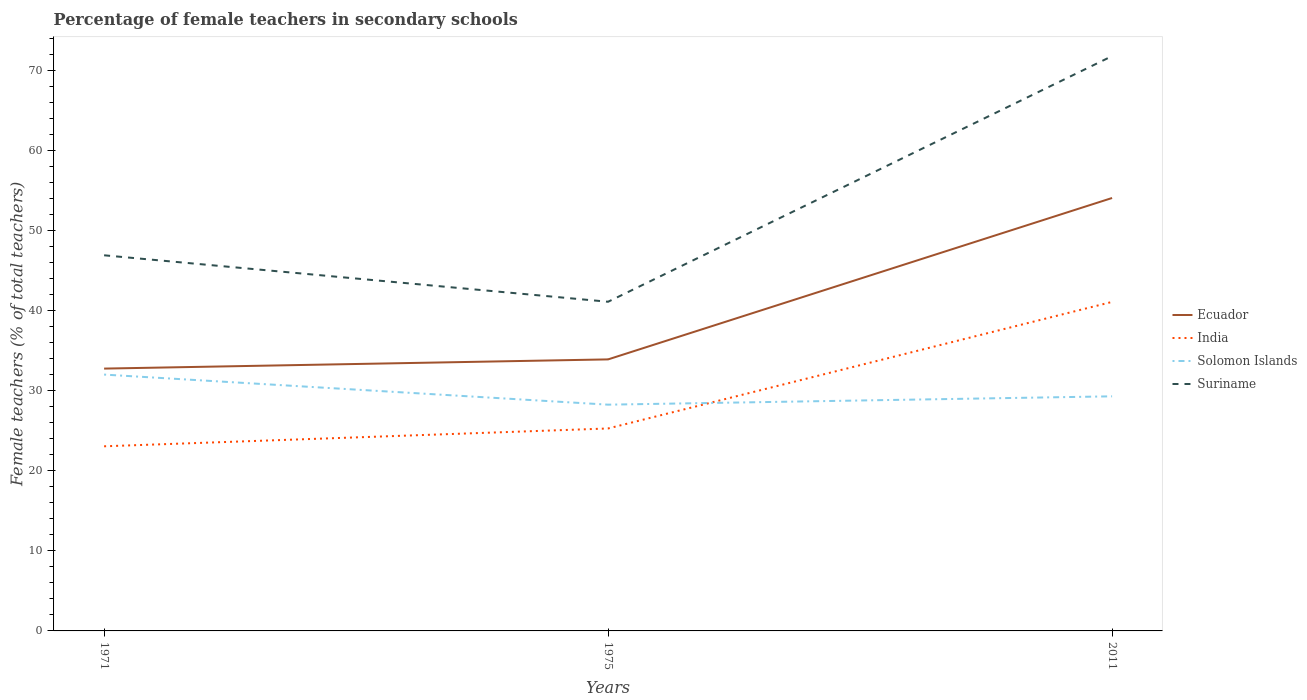Across all years, what is the maximum percentage of female teachers in Solomon Islands?
Keep it short and to the point. 28.24. In which year was the percentage of female teachers in Suriname maximum?
Your response must be concise. 1975. What is the total percentage of female teachers in India in the graph?
Your answer should be compact. -18.03. What is the difference between the highest and the second highest percentage of female teachers in India?
Give a very brief answer. 18.03. How many years are there in the graph?
Your answer should be very brief. 3. What is the difference between two consecutive major ticks on the Y-axis?
Give a very brief answer. 10. Where does the legend appear in the graph?
Give a very brief answer. Center right. How many legend labels are there?
Offer a terse response. 4. What is the title of the graph?
Offer a very short reply. Percentage of female teachers in secondary schools. What is the label or title of the X-axis?
Your answer should be compact. Years. What is the label or title of the Y-axis?
Your response must be concise. Female teachers (% of total teachers). What is the Female teachers (% of total teachers) in Ecuador in 1971?
Your answer should be compact. 32.75. What is the Female teachers (% of total teachers) in India in 1971?
Offer a very short reply. 23.05. What is the Female teachers (% of total teachers) of Solomon Islands in 1971?
Your response must be concise. 32. What is the Female teachers (% of total teachers) of Suriname in 1971?
Make the answer very short. 46.89. What is the Female teachers (% of total teachers) of Ecuador in 1975?
Ensure brevity in your answer.  33.9. What is the Female teachers (% of total teachers) in India in 1975?
Give a very brief answer. 25.27. What is the Female teachers (% of total teachers) in Solomon Islands in 1975?
Keep it short and to the point. 28.24. What is the Female teachers (% of total teachers) in Suriname in 1975?
Make the answer very short. 41.09. What is the Female teachers (% of total teachers) of Ecuador in 2011?
Your answer should be very brief. 54.04. What is the Female teachers (% of total teachers) in India in 2011?
Ensure brevity in your answer.  41.07. What is the Female teachers (% of total teachers) of Solomon Islands in 2011?
Your answer should be compact. 29.29. What is the Female teachers (% of total teachers) in Suriname in 2011?
Offer a terse response. 71.76. Across all years, what is the maximum Female teachers (% of total teachers) of Ecuador?
Provide a succinct answer. 54.04. Across all years, what is the maximum Female teachers (% of total teachers) of India?
Make the answer very short. 41.07. Across all years, what is the maximum Female teachers (% of total teachers) of Solomon Islands?
Provide a short and direct response. 32. Across all years, what is the maximum Female teachers (% of total teachers) of Suriname?
Provide a succinct answer. 71.76. Across all years, what is the minimum Female teachers (% of total teachers) of Ecuador?
Provide a succinct answer. 32.75. Across all years, what is the minimum Female teachers (% of total teachers) in India?
Give a very brief answer. 23.05. Across all years, what is the minimum Female teachers (% of total teachers) of Solomon Islands?
Offer a terse response. 28.24. Across all years, what is the minimum Female teachers (% of total teachers) in Suriname?
Keep it short and to the point. 41.09. What is the total Female teachers (% of total teachers) in Ecuador in the graph?
Offer a very short reply. 120.69. What is the total Female teachers (% of total teachers) in India in the graph?
Keep it short and to the point. 89.39. What is the total Female teachers (% of total teachers) of Solomon Islands in the graph?
Make the answer very short. 89.53. What is the total Female teachers (% of total teachers) of Suriname in the graph?
Your answer should be very brief. 159.74. What is the difference between the Female teachers (% of total teachers) of Ecuador in 1971 and that in 1975?
Make the answer very short. -1.15. What is the difference between the Female teachers (% of total teachers) in India in 1971 and that in 1975?
Give a very brief answer. -2.23. What is the difference between the Female teachers (% of total teachers) in Solomon Islands in 1971 and that in 1975?
Make the answer very short. 3.76. What is the difference between the Female teachers (% of total teachers) in Suriname in 1971 and that in 1975?
Make the answer very short. 5.8. What is the difference between the Female teachers (% of total teachers) of Ecuador in 1971 and that in 2011?
Your answer should be very brief. -21.3. What is the difference between the Female teachers (% of total teachers) in India in 1971 and that in 2011?
Give a very brief answer. -18.03. What is the difference between the Female teachers (% of total teachers) in Solomon Islands in 1971 and that in 2011?
Provide a succinct answer. 2.71. What is the difference between the Female teachers (% of total teachers) of Suriname in 1971 and that in 2011?
Provide a succinct answer. -24.87. What is the difference between the Female teachers (% of total teachers) in Ecuador in 1975 and that in 2011?
Provide a short and direct response. -20.15. What is the difference between the Female teachers (% of total teachers) in India in 1975 and that in 2011?
Your answer should be very brief. -15.8. What is the difference between the Female teachers (% of total teachers) of Solomon Islands in 1975 and that in 2011?
Your response must be concise. -1.04. What is the difference between the Female teachers (% of total teachers) of Suriname in 1975 and that in 2011?
Provide a short and direct response. -30.67. What is the difference between the Female teachers (% of total teachers) of Ecuador in 1971 and the Female teachers (% of total teachers) of India in 1975?
Offer a very short reply. 7.47. What is the difference between the Female teachers (% of total teachers) of Ecuador in 1971 and the Female teachers (% of total teachers) of Solomon Islands in 1975?
Provide a succinct answer. 4.5. What is the difference between the Female teachers (% of total teachers) of Ecuador in 1971 and the Female teachers (% of total teachers) of Suriname in 1975?
Provide a short and direct response. -8.34. What is the difference between the Female teachers (% of total teachers) in India in 1971 and the Female teachers (% of total teachers) in Solomon Islands in 1975?
Give a very brief answer. -5.2. What is the difference between the Female teachers (% of total teachers) in India in 1971 and the Female teachers (% of total teachers) in Suriname in 1975?
Ensure brevity in your answer.  -18.04. What is the difference between the Female teachers (% of total teachers) of Solomon Islands in 1971 and the Female teachers (% of total teachers) of Suriname in 1975?
Provide a short and direct response. -9.09. What is the difference between the Female teachers (% of total teachers) in Ecuador in 1971 and the Female teachers (% of total teachers) in India in 2011?
Provide a short and direct response. -8.33. What is the difference between the Female teachers (% of total teachers) in Ecuador in 1971 and the Female teachers (% of total teachers) in Solomon Islands in 2011?
Provide a short and direct response. 3.46. What is the difference between the Female teachers (% of total teachers) in Ecuador in 1971 and the Female teachers (% of total teachers) in Suriname in 2011?
Your answer should be compact. -39.01. What is the difference between the Female teachers (% of total teachers) of India in 1971 and the Female teachers (% of total teachers) of Solomon Islands in 2011?
Your response must be concise. -6.24. What is the difference between the Female teachers (% of total teachers) of India in 1971 and the Female teachers (% of total teachers) of Suriname in 2011?
Offer a very short reply. -48.71. What is the difference between the Female teachers (% of total teachers) of Solomon Islands in 1971 and the Female teachers (% of total teachers) of Suriname in 2011?
Your answer should be compact. -39.76. What is the difference between the Female teachers (% of total teachers) of Ecuador in 1975 and the Female teachers (% of total teachers) of India in 2011?
Ensure brevity in your answer.  -7.18. What is the difference between the Female teachers (% of total teachers) in Ecuador in 1975 and the Female teachers (% of total teachers) in Solomon Islands in 2011?
Make the answer very short. 4.61. What is the difference between the Female teachers (% of total teachers) of Ecuador in 1975 and the Female teachers (% of total teachers) of Suriname in 2011?
Provide a succinct answer. -37.86. What is the difference between the Female teachers (% of total teachers) in India in 1975 and the Female teachers (% of total teachers) in Solomon Islands in 2011?
Ensure brevity in your answer.  -4.01. What is the difference between the Female teachers (% of total teachers) of India in 1975 and the Female teachers (% of total teachers) of Suriname in 2011?
Make the answer very short. -46.49. What is the difference between the Female teachers (% of total teachers) in Solomon Islands in 1975 and the Female teachers (% of total teachers) in Suriname in 2011?
Provide a succinct answer. -43.51. What is the average Female teachers (% of total teachers) of Ecuador per year?
Ensure brevity in your answer.  40.23. What is the average Female teachers (% of total teachers) of India per year?
Provide a short and direct response. 29.8. What is the average Female teachers (% of total teachers) of Solomon Islands per year?
Offer a very short reply. 29.84. What is the average Female teachers (% of total teachers) in Suriname per year?
Give a very brief answer. 53.25. In the year 1971, what is the difference between the Female teachers (% of total teachers) of Ecuador and Female teachers (% of total teachers) of India?
Keep it short and to the point. 9.7. In the year 1971, what is the difference between the Female teachers (% of total teachers) of Ecuador and Female teachers (% of total teachers) of Solomon Islands?
Make the answer very short. 0.75. In the year 1971, what is the difference between the Female teachers (% of total teachers) of Ecuador and Female teachers (% of total teachers) of Suriname?
Provide a short and direct response. -14.14. In the year 1971, what is the difference between the Female teachers (% of total teachers) of India and Female teachers (% of total teachers) of Solomon Islands?
Offer a terse response. -8.95. In the year 1971, what is the difference between the Female teachers (% of total teachers) of India and Female teachers (% of total teachers) of Suriname?
Your response must be concise. -23.84. In the year 1971, what is the difference between the Female teachers (% of total teachers) in Solomon Islands and Female teachers (% of total teachers) in Suriname?
Make the answer very short. -14.89. In the year 1975, what is the difference between the Female teachers (% of total teachers) of Ecuador and Female teachers (% of total teachers) of India?
Provide a short and direct response. 8.62. In the year 1975, what is the difference between the Female teachers (% of total teachers) in Ecuador and Female teachers (% of total teachers) in Solomon Islands?
Your answer should be very brief. 5.65. In the year 1975, what is the difference between the Female teachers (% of total teachers) in Ecuador and Female teachers (% of total teachers) in Suriname?
Ensure brevity in your answer.  -7.19. In the year 1975, what is the difference between the Female teachers (% of total teachers) in India and Female teachers (% of total teachers) in Solomon Islands?
Give a very brief answer. -2.97. In the year 1975, what is the difference between the Female teachers (% of total teachers) in India and Female teachers (% of total teachers) in Suriname?
Provide a succinct answer. -15.82. In the year 1975, what is the difference between the Female teachers (% of total teachers) in Solomon Islands and Female teachers (% of total teachers) in Suriname?
Ensure brevity in your answer.  -12.85. In the year 2011, what is the difference between the Female teachers (% of total teachers) of Ecuador and Female teachers (% of total teachers) of India?
Make the answer very short. 12.97. In the year 2011, what is the difference between the Female teachers (% of total teachers) in Ecuador and Female teachers (% of total teachers) in Solomon Islands?
Ensure brevity in your answer.  24.76. In the year 2011, what is the difference between the Female teachers (% of total teachers) of Ecuador and Female teachers (% of total teachers) of Suriname?
Make the answer very short. -17.71. In the year 2011, what is the difference between the Female teachers (% of total teachers) of India and Female teachers (% of total teachers) of Solomon Islands?
Ensure brevity in your answer.  11.79. In the year 2011, what is the difference between the Female teachers (% of total teachers) of India and Female teachers (% of total teachers) of Suriname?
Ensure brevity in your answer.  -30.69. In the year 2011, what is the difference between the Female teachers (% of total teachers) in Solomon Islands and Female teachers (% of total teachers) in Suriname?
Your response must be concise. -42.47. What is the ratio of the Female teachers (% of total teachers) in Ecuador in 1971 to that in 1975?
Keep it short and to the point. 0.97. What is the ratio of the Female teachers (% of total teachers) of India in 1971 to that in 1975?
Offer a terse response. 0.91. What is the ratio of the Female teachers (% of total teachers) in Solomon Islands in 1971 to that in 1975?
Provide a short and direct response. 1.13. What is the ratio of the Female teachers (% of total teachers) in Suriname in 1971 to that in 1975?
Provide a succinct answer. 1.14. What is the ratio of the Female teachers (% of total teachers) of Ecuador in 1971 to that in 2011?
Give a very brief answer. 0.61. What is the ratio of the Female teachers (% of total teachers) in India in 1971 to that in 2011?
Your response must be concise. 0.56. What is the ratio of the Female teachers (% of total teachers) of Solomon Islands in 1971 to that in 2011?
Give a very brief answer. 1.09. What is the ratio of the Female teachers (% of total teachers) of Suriname in 1971 to that in 2011?
Provide a succinct answer. 0.65. What is the ratio of the Female teachers (% of total teachers) of Ecuador in 1975 to that in 2011?
Offer a terse response. 0.63. What is the ratio of the Female teachers (% of total teachers) in India in 1975 to that in 2011?
Your response must be concise. 0.62. What is the ratio of the Female teachers (% of total teachers) of Solomon Islands in 1975 to that in 2011?
Your answer should be compact. 0.96. What is the ratio of the Female teachers (% of total teachers) in Suriname in 1975 to that in 2011?
Make the answer very short. 0.57. What is the difference between the highest and the second highest Female teachers (% of total teachers) in Ecuador?
Your response must be concise. 20.15. What is the difference between the highest and the second highest Female teachers (% of total teachers) in India?
Keep it short and to the point. 15.8. What is the difference between the highest and the second highest Female teachers (% of total teachers) in Solomon Islands?
Provide a short and direct response. 2.71. What is the difference between the highest and the second highest Female teachers (% of total teachers) of Suriname?
Ensure brevity in your answer.  24.87. What is the difference between the highest and the lowest Female teachers (% of total teachers) of Ecuador?
Your answer should be very brief. 21.3. What is the difference between the highest and the lowest Female teachers (% of total teachers) of India?
Your answer should be compact. 18.03. What is the difference between the highest and the lowest Female teachers (% of total teachers) in Solomon Islands?
Your response must be concise. 3.76. What is the difference between the highest and the lowest Female teachers (% of total teachers) in Suriname?
Provide a short and direct response. 30.67. 